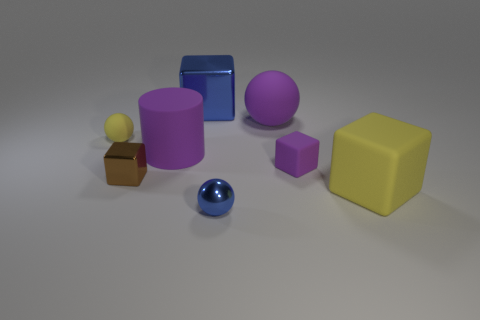There is another block that is the same size as the purple rubber cube; what color is it?
Offer a terse response. Brown. Is there a block that has the same color as the big matte ball?
Offer a very short reply. Yes. There is a yellow matte thing that is to the right of the purple matte sphere; is it the same shape as the yellow thing on the left side of the big blue block?
Your answer should be very brief. No. The thing that is the same color as the metallic sphere is what size?
Keep it short and to the point. Large. How many other things are there of the same size as the yellow cube?
Ensure brevity in your answer.  3. There is a matte cylinder; is its color the same as the small object in front of the brown metallic thing?
Your answer should be very brief. No. Is the number of small yellow balls to the right of the small shiny sphere less than the number of purple matte things in front of the small purple block?
Your answer should be very brief. No. There is a object that is both to the left of the big yellow matte thing and in front of the tiny metallic cube; what is its color?
Offer a very short reply. Blue. Does the purple matte ball have the same size as the yellow rubber thing to the right of the big blue block?
Give a very brief answer. Yes. There is a rubber object that is left of the small metallic cube; what shape is it?
Keep it short and to the point. Sphere. 